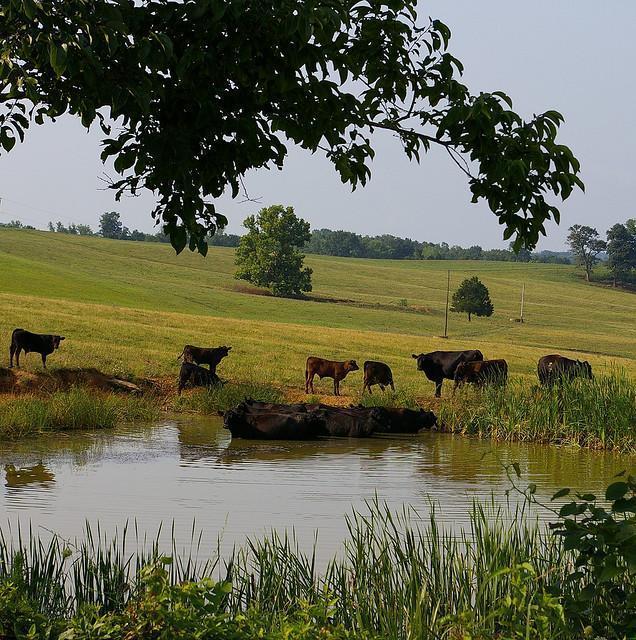How many train cars are in the image?
Give a very brief answer. 0. 